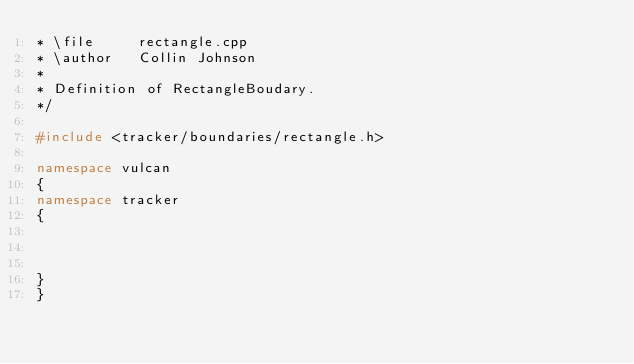Convert code to text. <code><loc_0><loc_0><loc_500><loc_500><_C++_>* \file     rectangle.cpp
* \author   Collin Johnson
*
* Definition of RectangleBoudary.
*/

#include <tracker/boundaries/rectangle.h>

namespace vulcan
{
namespace tracker
{



}
}
</code> 